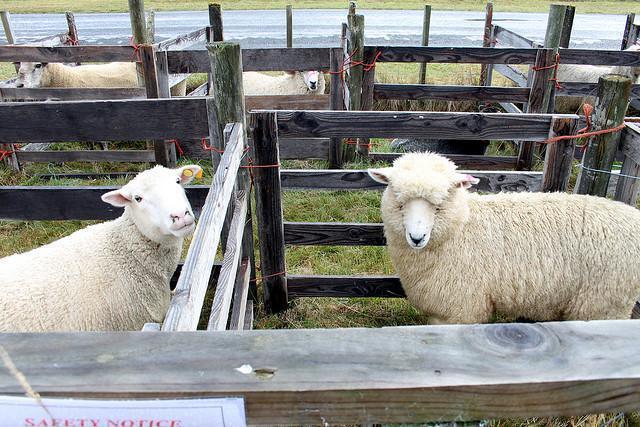What color is the twine that is tied between the cages carrying sheep?
Choose the right answer from the provided options to respond to the question.
Options: Green, pink, red, blue. Red. 